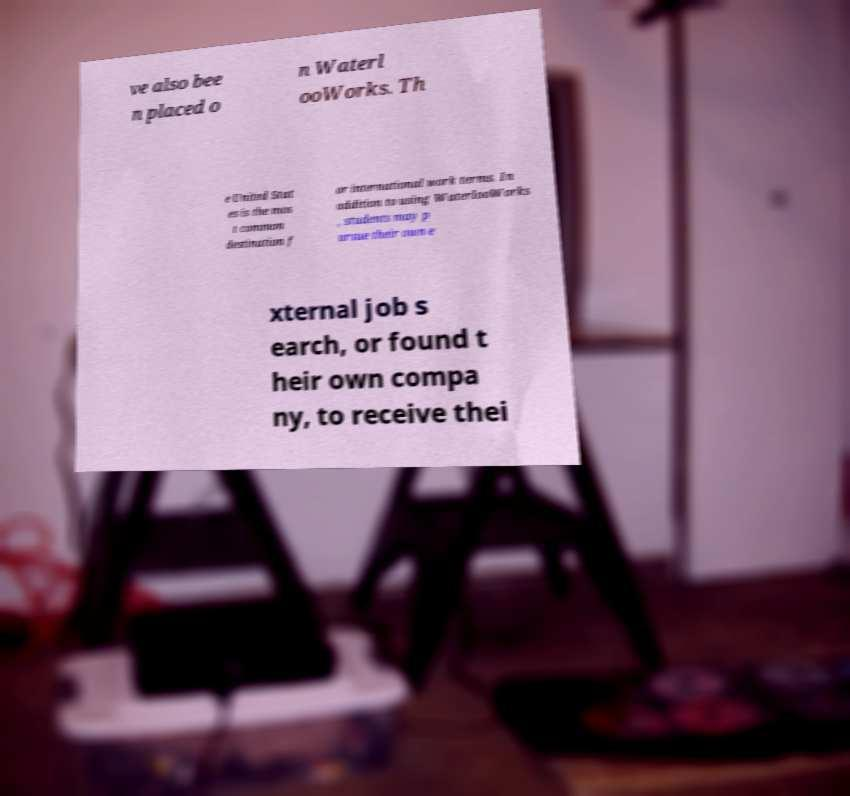Could you assist in decoding the text presented in this image and type it out clearly? ve also bee n placed o n Waterl ooWorks. Th e United Stat es is the mos t common destination f or international work terms. In addition to using WaterlooWorks , students may p ursue their own e xternal job s earch, or found t heir own compa ny, to receive thei 